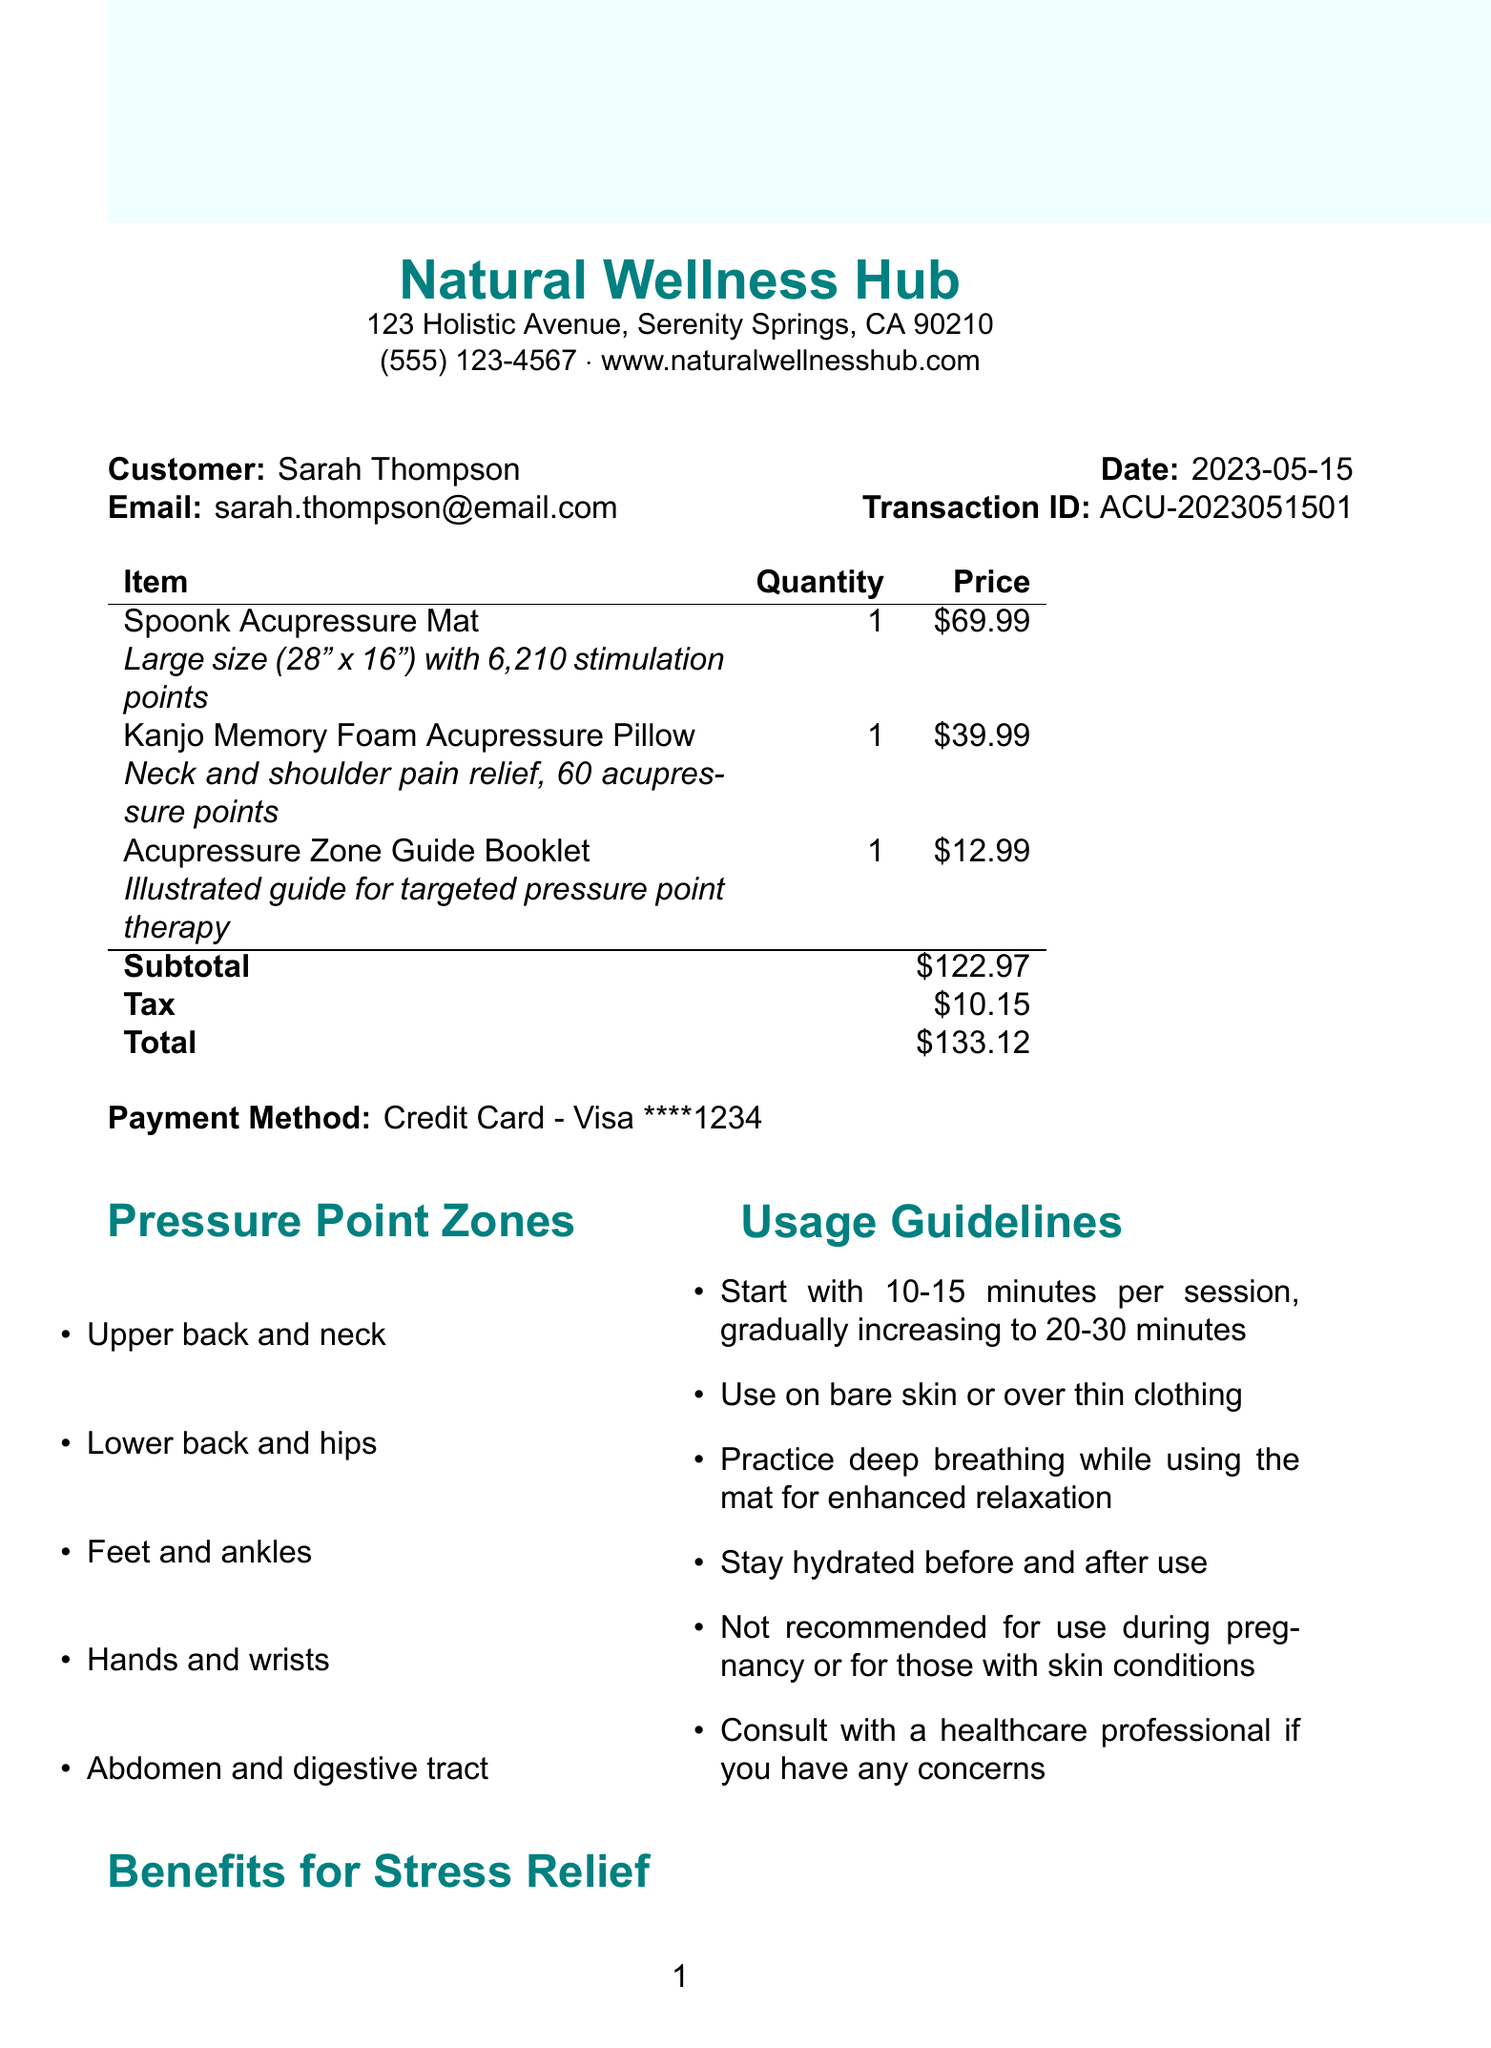what is the store name? The store name is listed in the header of the receipt, which shows "Natural Wellness Hub."
Answer: Natural Wellness Hub what is the transaction date? The transaction date is specified in the receipt as "2023-05-15."
Answer: 2023-05-15 how many stimulation points does the acupressure mat have? The description of the acupressure mat states that it has "6,210 stimulation points."
Answer: 6,210 stimulation points what is the subtotal amount? The subtotal is clearly indicated in the summary of the receipt as "$122.97."
Answer: $122.97 how long should you start using the acupressure mat? The usage guidelines specifically recommend starting with "10-15 minutes per session."
Answer: 10-15 minutes what pressure point zone is not mentioned? By evaluating the zones listed, "Head and neck" is not included in the list of pressure point zones.
Answer: Head and neck what are the benefits of using the acupressure mat? The section on benefits lists several outcomes, including "Promotes release of endorphins."
Answer: Promotes release of endorphins how much did the acupressure pillow cost? The price of the acupressure pillow is stated as "$39.99."
Answer: $39.99 who is the customer listed in the receipt? The customer's name is presented at the top of the receipt, which is "Sarah Thompson."
Answer: Sarah Thompson 